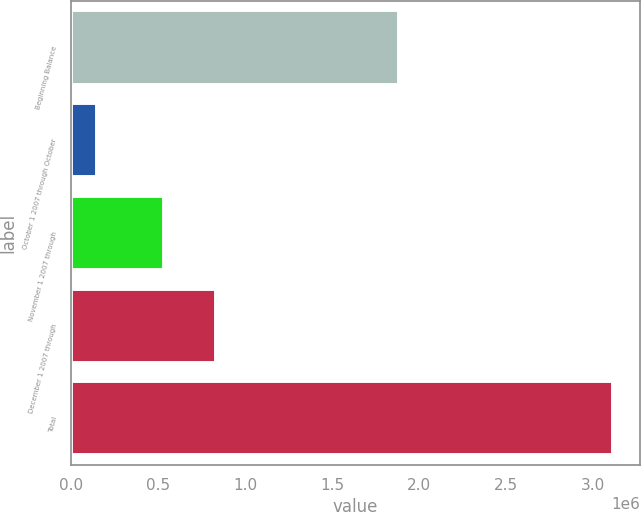Convert chart to OTSL. <chart><loc_0><loc_0><loc_500><loc_500><bar_chart><fcel>Beginning Balance<fcel>October 1 2007 through October<fcel>November 1 2007 through<fcel>December 1 2007 through<fcel>Total<nl><fcel>1.8822e+06<fcel>150000<fcel>536000<fcel>832450<fcel>3.1145e+06<nl></chart> 